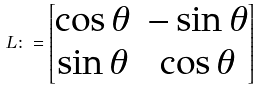Convert formula to latex. <formula><loc_0><loc_0><loc_500><loc_500>L \colon = \begin{bmatrix} \cos \theta & - \sin \theta \\ \sin \theta & \cos \theta \end{bmatrix}</formula> 